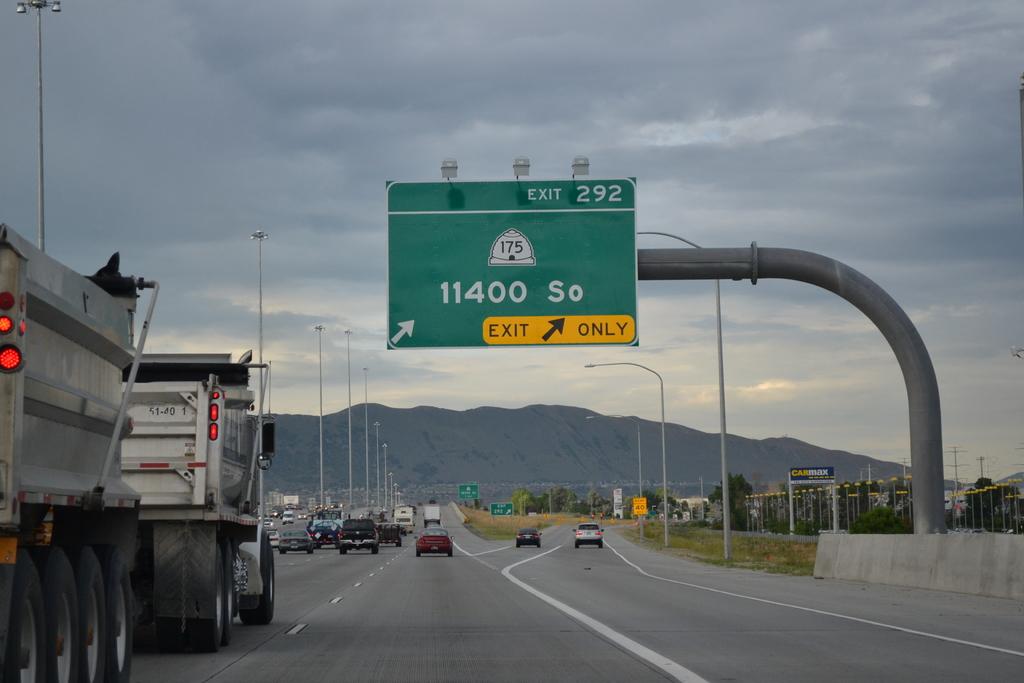Is this an exit only?
Your answer should be very brief. Yes. 